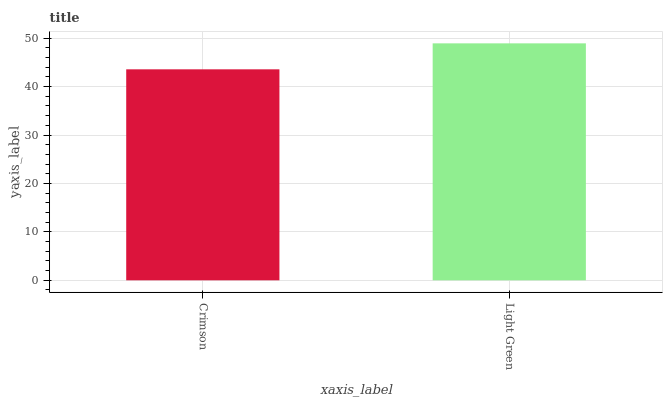Is Light Green the minimum?
Answer yes or no. No. Is Light Green greater than Crimson?
Answer yes or no. Yes. Is Crimson less than Light Green?
Answer yes or no. Yes. Is Crimson greater than Light Green?
Answer yes or no. No. Is Light Green less than Crimson?
Answer yes or no. No. Is Light Green the high median?
Answer yes or no. Yes. Is Crimson the low median?
Answer yes or no. Yes. Is Crimson the high median?
Answer yes or no. No. Is Light Green the low median?
Answer yes or no. No. 